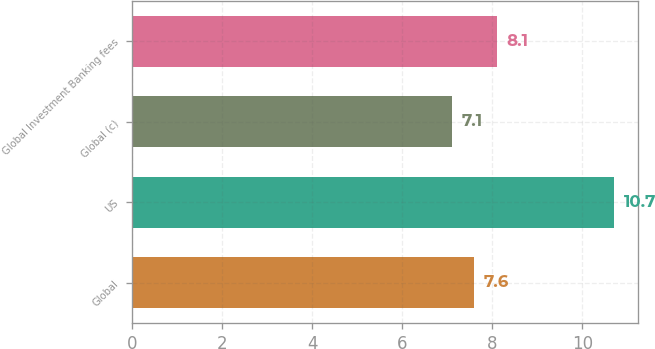Convert chart. <chart><loc_0><loc_0><loc_500><loc_500><bar_chart><fcel>Global<fcel>US<fcel>Global (c)<fcel>Global Investment Banking fees<nl><fcel>7.6<fcel>10.7<fcel>7.1<fcel>8.1<nl></chart> 